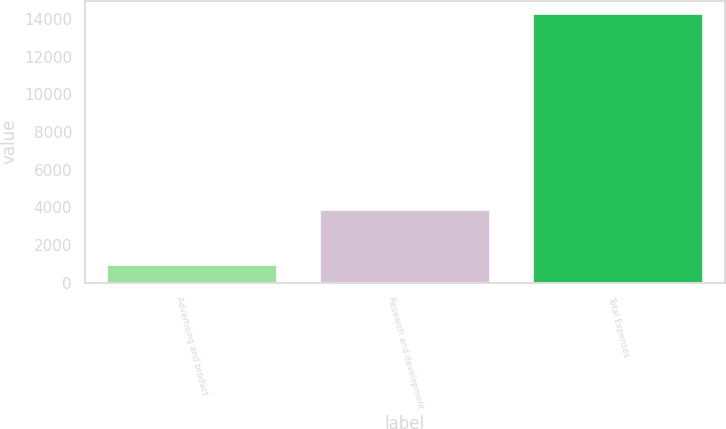Convert chart. <chart><loc_0><loc_0><loc_500><loc_500><bar_chart><fcel>Advertising and product<fcel>Research and development<fcel>Total Expenses<nl><fcel>957<fcel>3839<fcel>14263<nl></chart> 